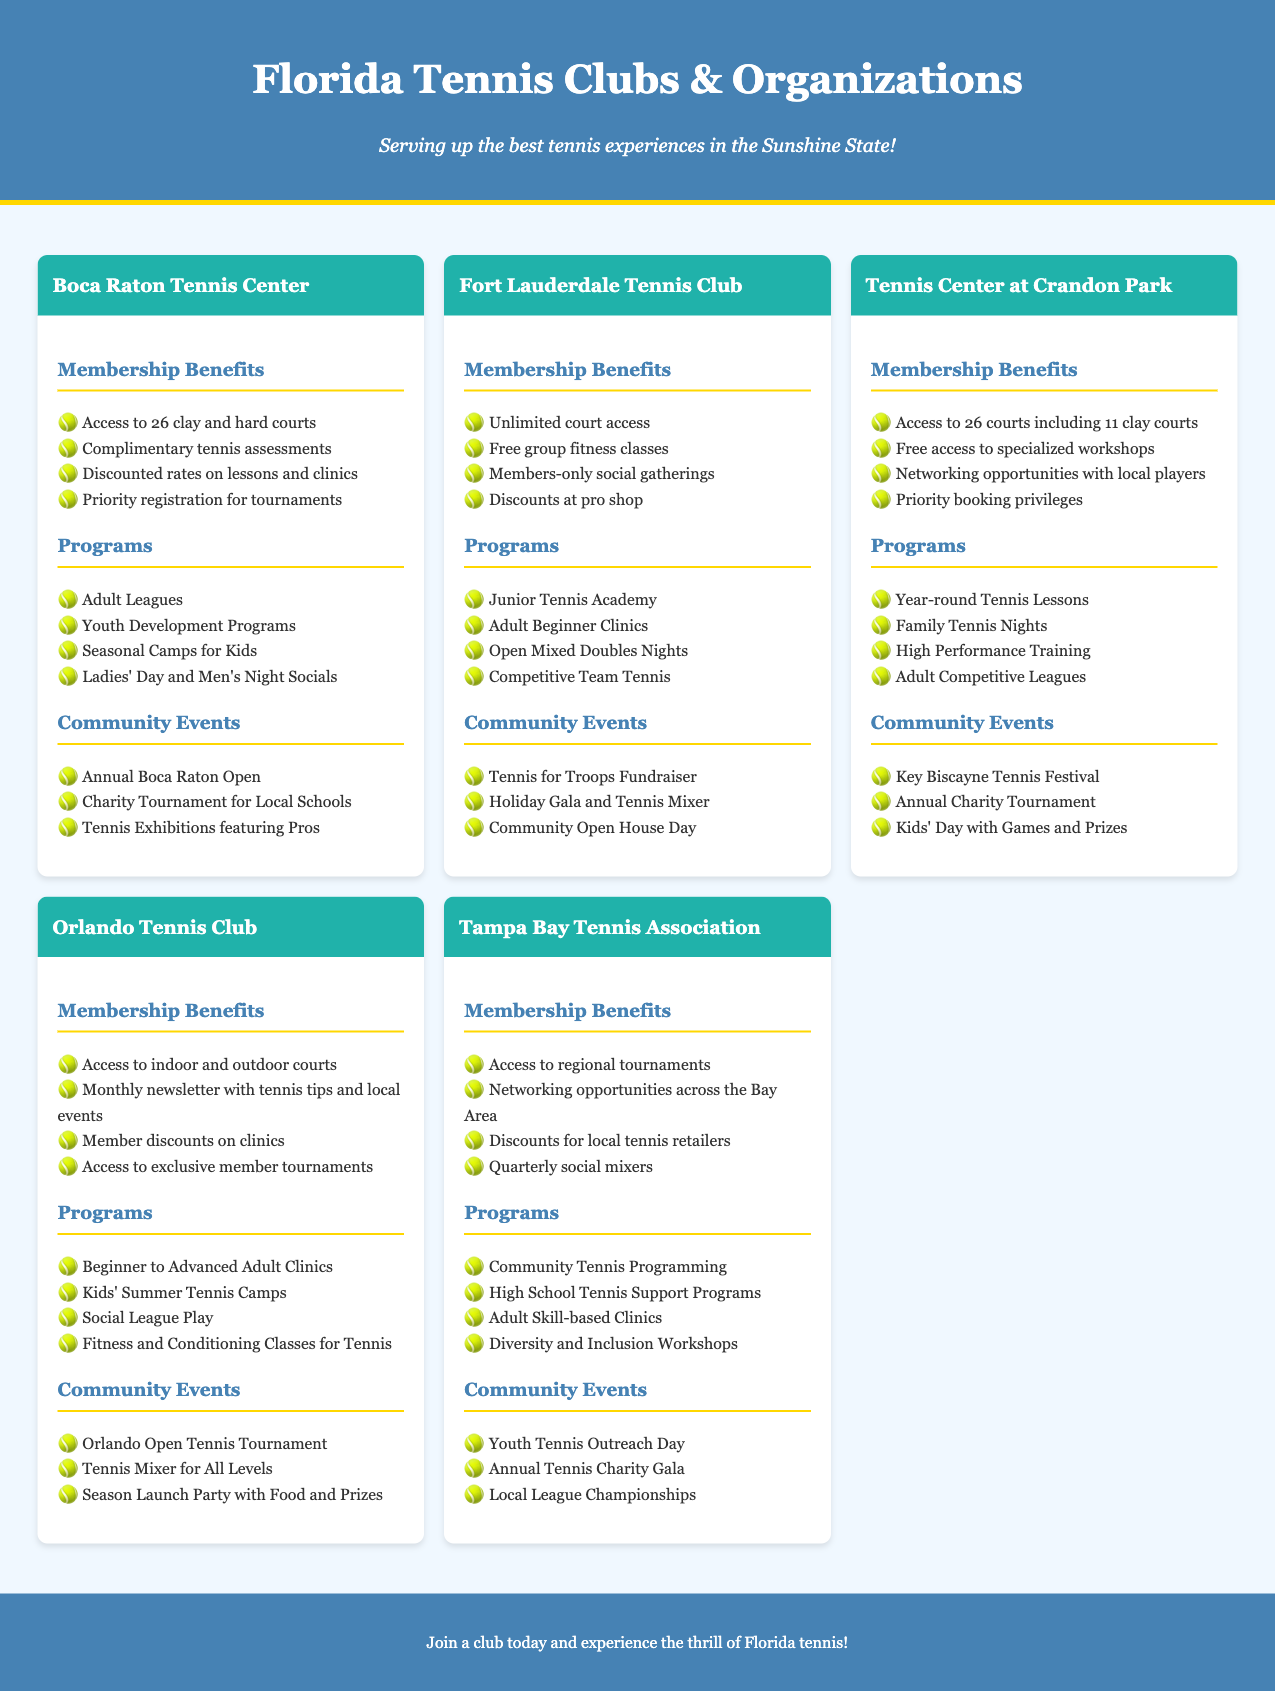What are the membership benefits at Boca Raton Tennis Center? The benefits include access to courts, complimentary assessments, discounted lessons, and tournament registration priority.
Answer: Access to 26 clay and hard courts, Complimentary tennis assessments, Discounted rates on lessons and clinics, Priority registration for tournaments How many courts are available at Tennis Center at Crandon Park? The document specifies the number of courts included in the club's benefits.
Answer: 26 courts including 11 clay courts What community event takes place at Orlando Tennis Club? The community events listed under Orlando Tennis Club include a specific tournament and mixer.
Answer: Orlando Open Tennis Tournament What type of programs does Fort Lauderdale Tennis Club offer for juniors? The programs mentioned for juniors are aimed at skill development and social play.
Answer: Junior Tennis Academy Which Florida tennis club has unlimited court access? This question seeks to identify which club offers a specific benefit related to court access.
Answer: Fort Lauderdale Tennis Club How many social gatherings are members of Fort Lauderdale Tennis Club invited to? Members-only gatherings indicate the social aspect of membership benefits.
Answer: Members-only social gatherings What is an example of a charity event hosted by the Boca Raton Tennis Center? The document provides specific examples of community events, including a charity aspect.
Answer: Charity Tournament for Local Schools How does Tampa Bay Tennis Association support high school tennis? This question addresses the club’s involvement in supporting local schools through tennis programs.
Answer: High School Tennis Support Programs What is the focus of the diversity workshops offered by Tampa Bay Tennis Association? This question examines the themes of inclusion present in the club's programs.
Answer: Diversity and Inclusion Workshops 